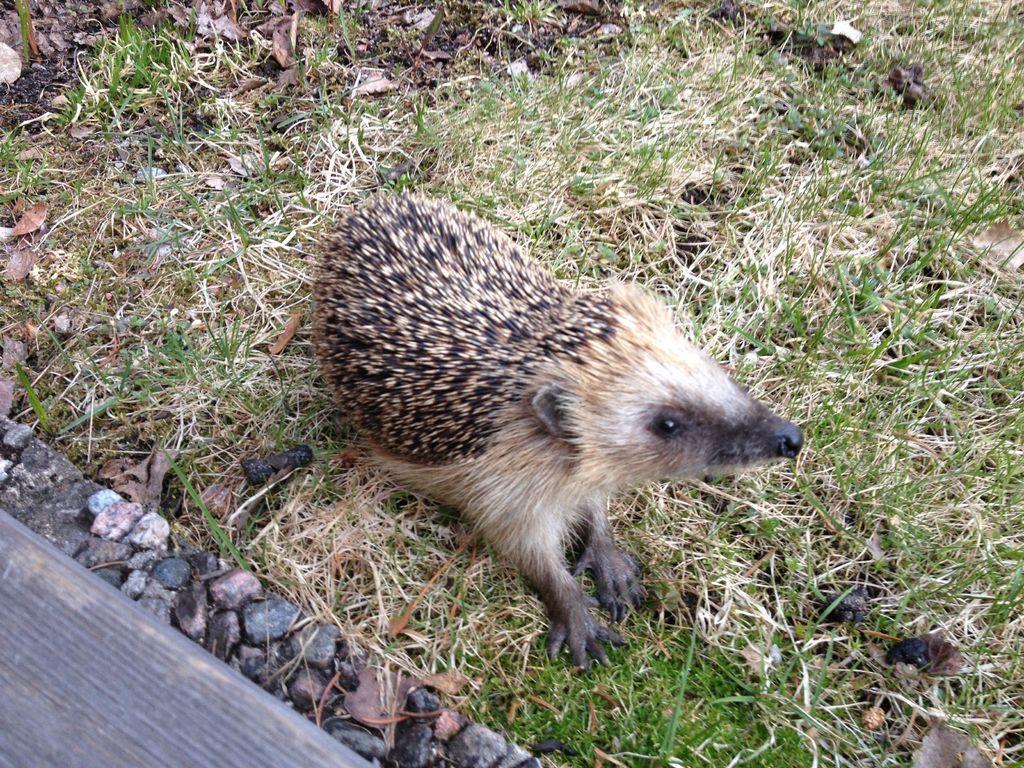Can you describe this image briefly? There is an animal on the ground. There is grass on the ground. Near to that there is a side wall with stones. 